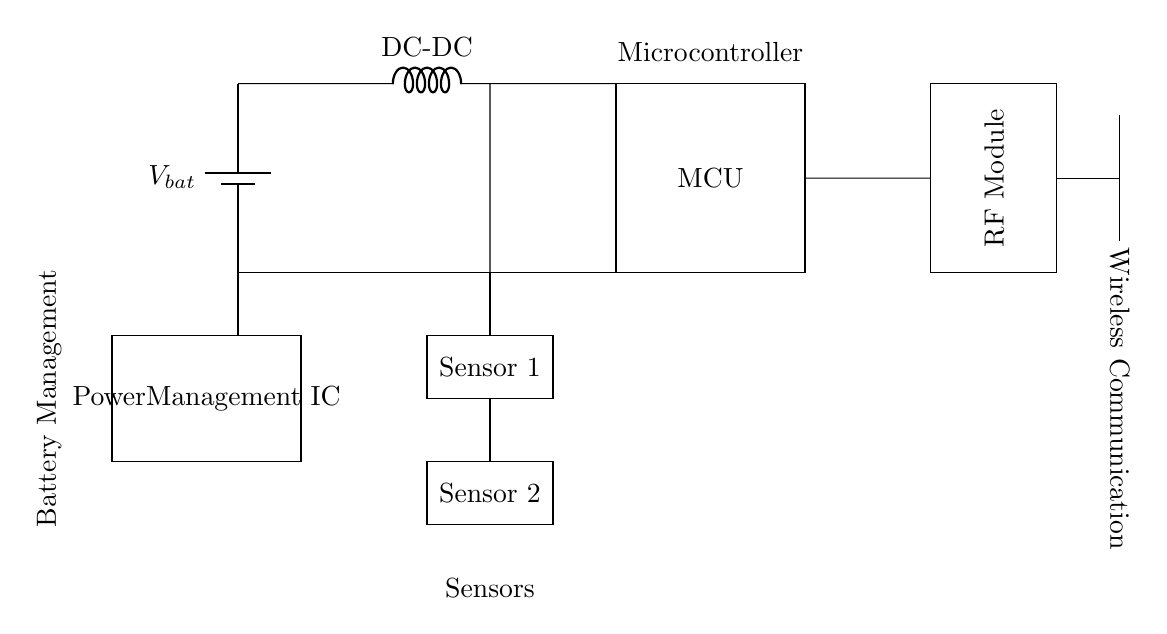What is the primary function of the MCU in this circuit? The MCU processes the data from sensors and manages communication with the RF module.
Answer: Data processing What type of energy source is represented in the circuit? The battery is depicted as a component providing electrical energy, identified by the battery symbol.
Answer: Battery How many sensors are shown in this circuit design? The diagram illustrates two sensors connected to the microcontroller, each marked accordingly.
Answer: Two What is the purpose of the RF module in the circuit? The RF module facilitates wireless communication by sending and receiving signals to connect with other devices.
Answer: Wireless communication What does the cute inductor labeled “DC-DC” indicate in terms of power management? The DC-DC inductor serves to convert and regulate the voltage levels suitable for system requirements.
Answer: Voltage regulation Which component is responsible for power management in the design? The Power Management IC oversees the distribution and management of power from the battery to other components.
Answer: Power Management IC What is the role of the antenna in the wireless communication section? The antenna transmits and receives radio frequency signals, enabling wireless connectivity for the device.
Answer: Signal transmission 